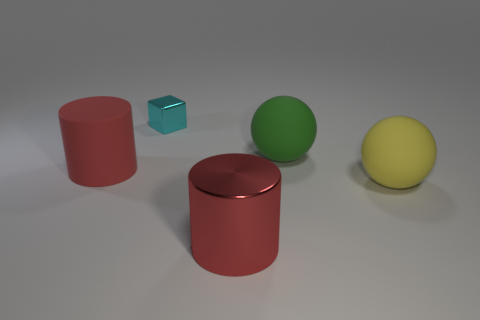Is the number of green spheres behind the cyan thing less than the number of small cyan cubes?
Ensure brevity in your answer.  Yes. What material is the cylinder to the left of the tiny cyan shiny thing?
Ensure brevity in your answer.  Rubber. What number of other objects are the same size as the shiny cylinder?
Ensure brevity in your answer.  3. Are there fewer yellow objects than big gray balls?
Your answer should be compact. No. The small cyan shiny object is what shape?
Offer a very short reply. Cube. Do the metallic object that is in front of the yellow matte thing and the block have the same color?
Offer a terse response. No. There is a rubber object that is left of the yellow rubber object and on the right side of the small cyan block; what is its shape?
Provide a short and direct response. Sphere. The cylinder that is right of the cyan metal thing is what color?
Make the answer very short. Red. Is there anything else that is the same color as the small metal cube?
Ensure brevity in your answer.  No. Do the shiny cylinder and the block have the same size?
Your answer should be very brief. No. 